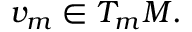<formula> <loc_0><loc_0><loc_500><loc_500>v _ { m } \in T _ { m } M .</formula> 